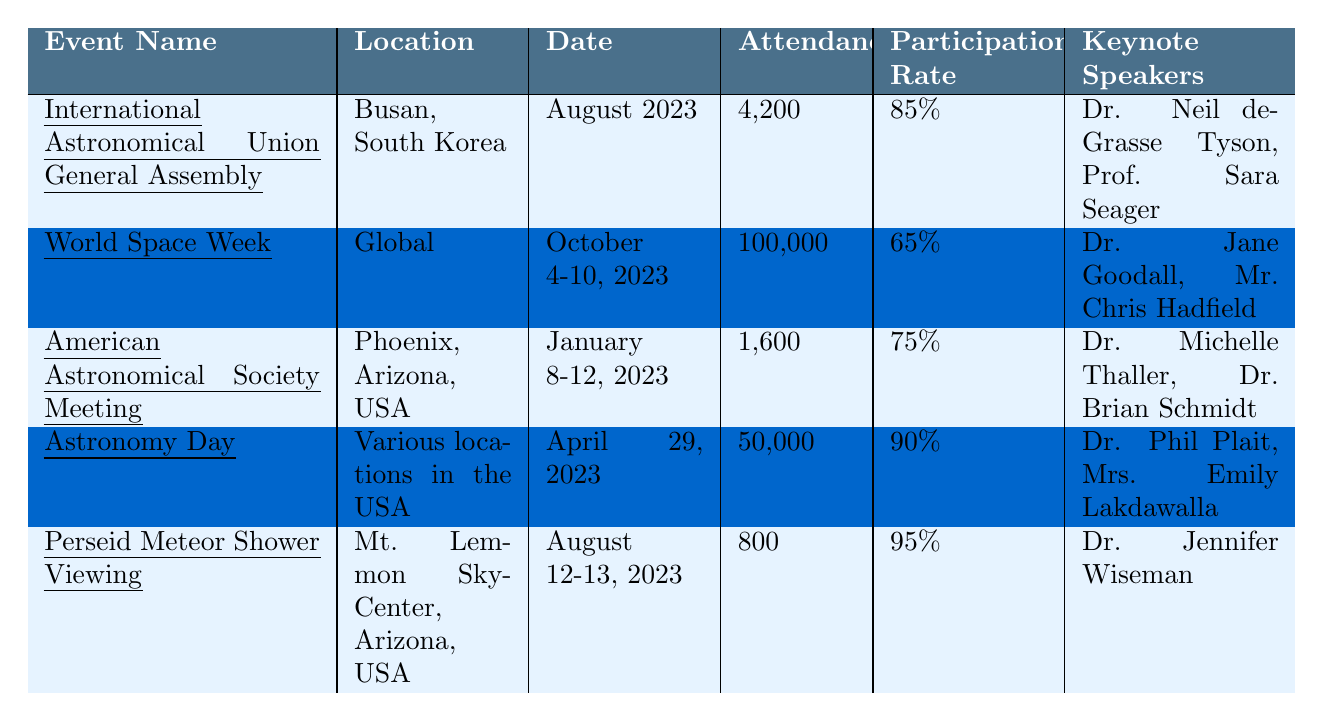What is the attendance at the World Space Week event? The attendance for World Space Week is listed directly in the table under the "Attendance" column, showing a value of 100,000.
Answer: 100,000 Which event had the highest participation rate? By comparing the participation rates in the table, I can see that the event with the highest rate is the Perseid Meteor Shower Viewing at 95%.
Answer: Perseid Meteor Shower Viewing How many workshops were conducted at the American Astronomical Society Meeting? The number of workshops is mentioned in the table for the American Astronomical Society Meeting, where it states there were 30 workshops.
Answer: 30 What is the difference in attendance between Astronomy Day and the American Astronomical Society Meeting? To find the difference, I subtract the attendance of the American Astronomical Society Meeting (1,600) from that of Astronomy Day (50,000), which gives me 50,000 - 1,600 = 48,400.
Answer: 48,400 Is it true that all events had keynote speakers? Looking at the table, every listed event has at least one keynote speaker mentioned, which confirms the statement is true.
Answer: True What is the average attendance across all listed events? To find the average attendance, I sum all attendances: 4,200 + 100,000 + 1,600 + 50,000 + 800 = 156,600. There are 5 events, so I divide 156,600 by 5, resulting in 31,320.
Answer: 31,320 Which event took place in August 2023? The table shows two events listed for August: the International Astronomical Union General Assembly and the Perseid Meteor Shower Viewing, confirming both took place in that month.
Answer: Two events How does the participation rate of the International Astronomical Union General Assembly compare to that of World Space Week? The participation rate for the International Astronomical Union General Assembly is 85%, while for World Space Week it is 65%. This indicates that the former has a higher rate by 20 percentage points.
Answer: 20 percentage points Was the attendance at the Perseid Meteor Shower Viewing higher than that of the American Astronomical Society Meeting? The table shows the attendance of the Perseid Meteor Shower Viewing was 800, while the American Astronomical Society Meeting had 1,600 attendees. Therefore, the attendance at the Perseid event was lower.
Answer: No 